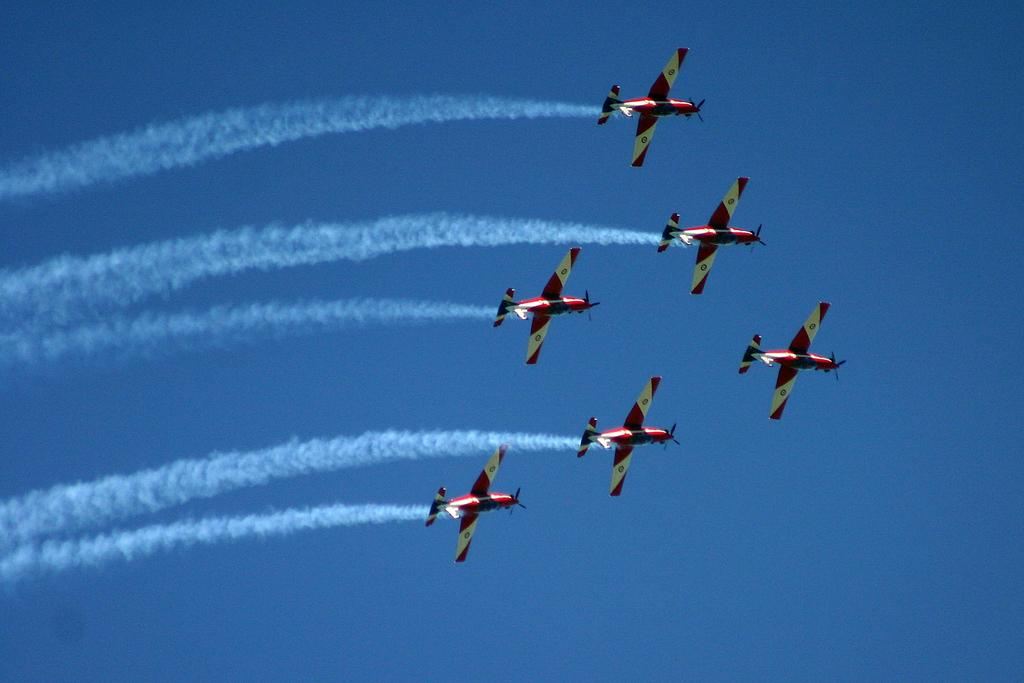Where was the image taken? The image is taken outdoors. What can be seen in the background of the image? There is the sky visible in the background. What is happening in the sky in the image? There are airplanes flying in the sky. What is the source of the smoke in the image? The smoke is present in the image, but the source is not specified. How many babies are crawling on the wheel in the image? There is no wheel or babies present in the image. 